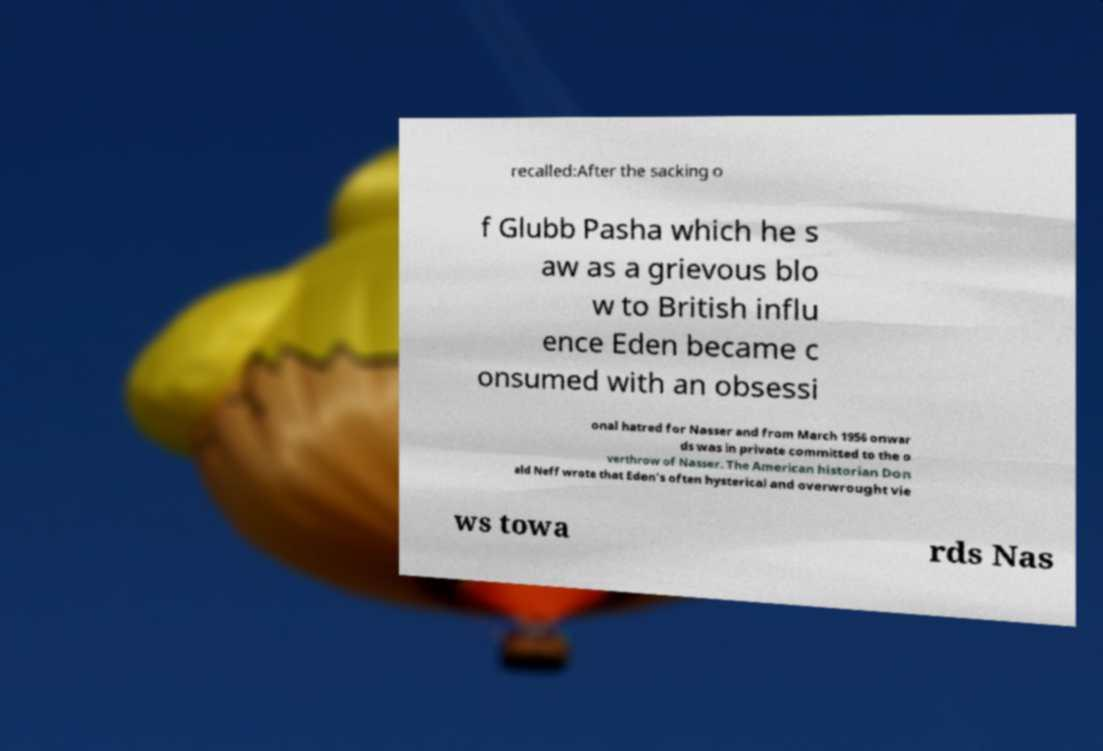Can you accurately transcribe the text from the provided image for me? recalled:After the sacking o f Glubb Pasha which he s aw as a grievous blo w to British influ ence Eden became c onsumed with an obsessi onal hatred for Nasser and from March 1956 onwar ds was in private committed to the o verthrow of Nasser. The American historian Don ald Neff wrote that Eden's often hysterical and overwrought vie ws towa rds Nas 